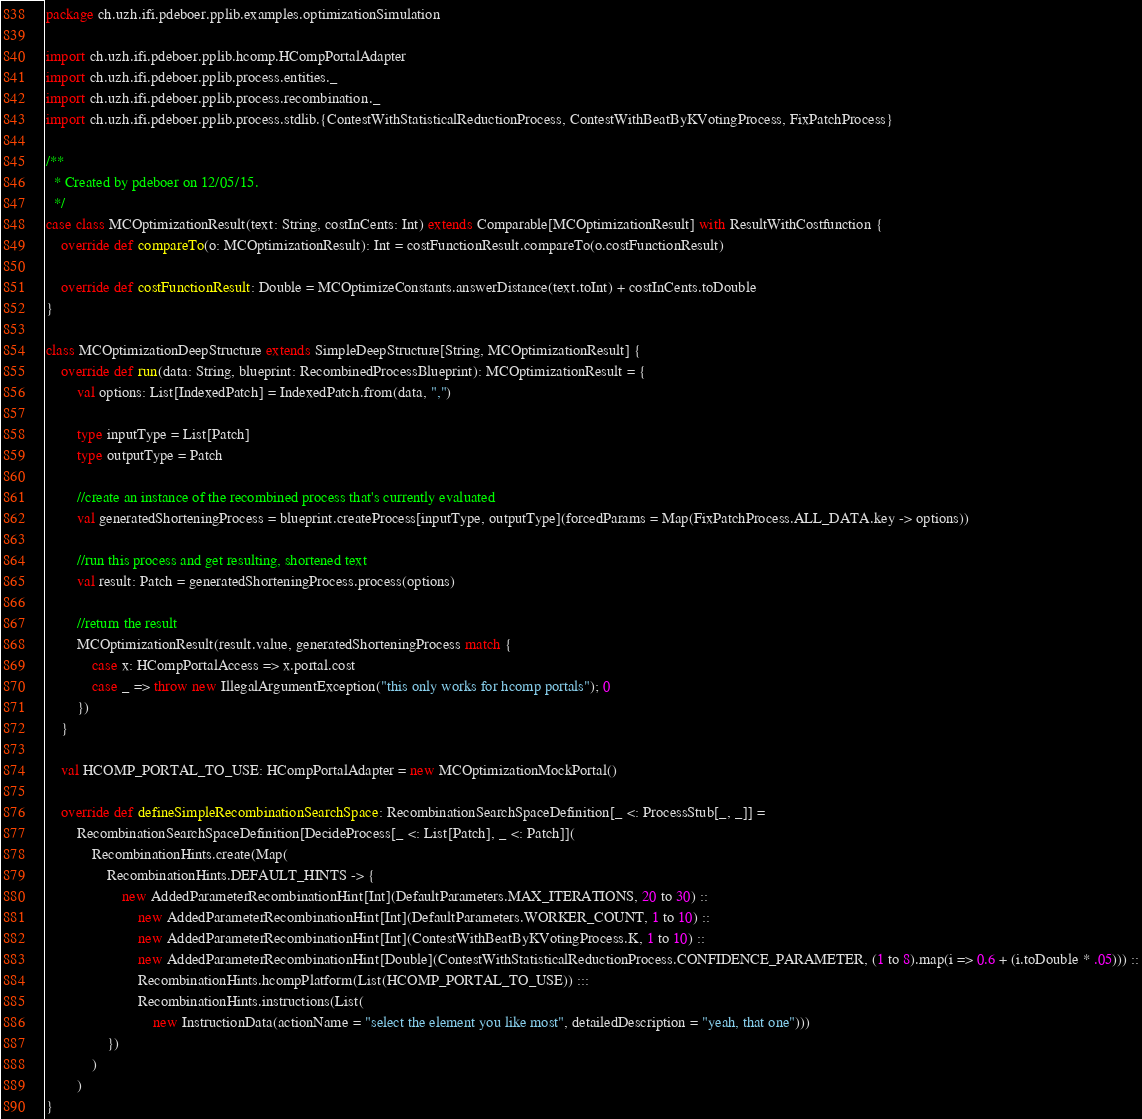<code> <loc_0><loc_0><loc_500><loc_500><_Scala_>package ch.uzh.ifi.pdeboer.pplib.examples.optimizationSimulation

import ch.uzh.ifi.pdeboer.pplib.hcomp.HCompPortalAdapter
import ch.uzh.ifi.pdeboer.pplib.process.entities._
import ch.uzh.ifi.pdeboer.pplib.process.recombination._
import ch.uzh.ifi.pdeboer.pplib.process.stdlib.{ContestWithStatisticalReductionProcess, ContestWithBeatByKVotingProcess, FixPatchProcess}

/**
  * Created by pdeboer on 12/05/15.
  */
case class MCOptimizationResult(text: String, costInCents: Int) extends Comparable[MCOptimizationResult] with ResultWithCostfunction {
	override def compareTo(o: MCOptimizationResult): Int = costFunctionResult.compareTo(o.costFunctionResult)

	override def costFunctionResult: Double = MCOptimizeConstants.answerDistance(text.toInt) + costInCents.toDouble
}

class MCOptimizationDeepStructure extends SimpleDeepStructure[String, MCOptimizationResult] {
	override def run(data: String, blueprint: RecombinedProcessBlueprint): MCOptimizationResult = {
		val options: List[IndexedPatch] = IndexedPatch.from(data, ",")

		type inputType = List[Patch]
		type outputType = Patch

		//create an instance of the recombined process that's currently evaluated
		val generatedShorteningProcess = blueprint.createProcess[inputType, outputType](forcedParams = Map(FixPatchProcess.ALL_DATA.key -> options))

		//run this process and get resulting, shortened text
		val result: Patch = generatedShorteningProcess.process(options)

		//return the result
		MCOptimizationResult(result.value, generatedShorteningProcess match {
			case x: HCompPortalAccess => x.portal.cost
			case _ => throw new IllegalArgumentException("this only works for hcomp portals"); 0
		})
	}

	val HCOMP_PORTAL_TO_USE: HCompPortalAdapter = new MCOptimizationMockPortal()

	override def defineSimpleRecombinationSearchSpace: RecombinationSearchSpaceDefinition[_ <: ProcessStub[_, _]] =
		RecombinationSearchSpaceDefinition[DecideProcess[_ <: List[Patch], _ <: Patch]](
			RecombinationHints.create(Map(
				RecombinationHints.DEFAULT_HINTS -> {
					new AddedParameterRecombinationHint[Int](DefaultParameters.MAX_ITERATIONS, 20 to 30) ::
						new AddedParameterRecombinationHint[Int](DefaultParameters.WORKER_COUNT, 1 to 10) ::
						new AddedParameterRecombinationHint[Int](ContestWithBeatByKVotingProcess.K, 1 to 10) ::
						new AddedParameterRecombinationHint[Double](ContestWithStatisticalReductionProcess.CONFIDENCE_PARAMETER, (1 to 8).map(i => 0.6 + (i.toDouble * .05))) ::
						RecombinationHints.hcompPlatform(List(HCOMP_PORTAL_TO_USE)) :::
						RecombinationHints.instructions(List(
							new InstructionData(actionName = "select the element you like most", detailedDescription = "yeah, that one")))
				})
			)
		)
}
</code> 